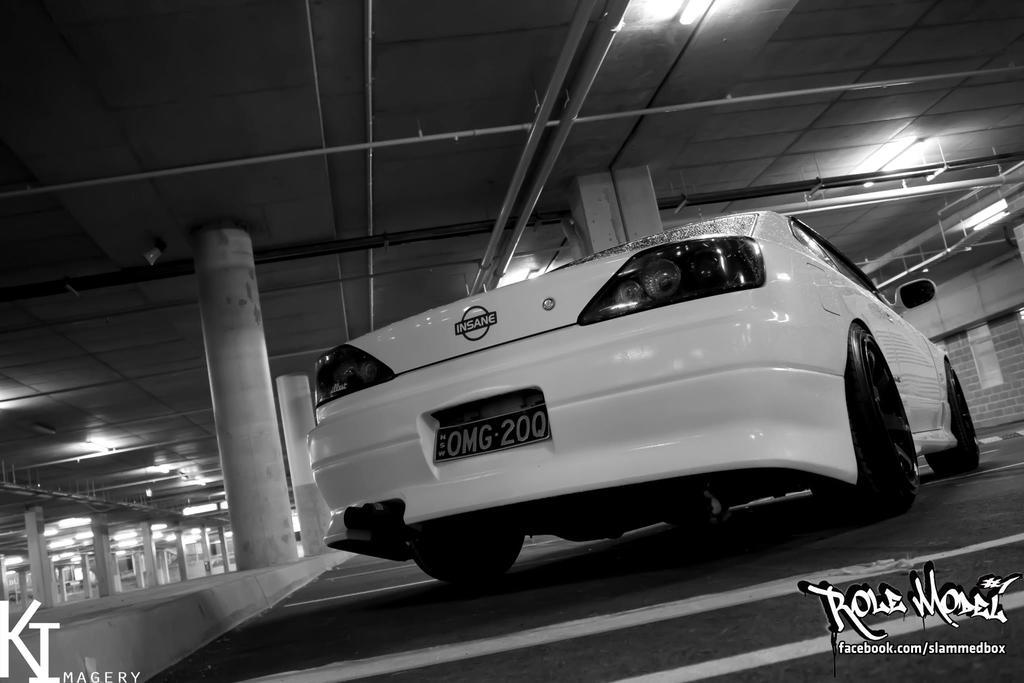What is the main subject in the foreground of the image? There is a car in the foreground of the image. Where is the car located in relation to the floor? The car is on the floor. What can be seen in the background of the image? There are pillars and lights attached to the ceiling in the background of the image. What type of plate is being used to protect the car from pests in the image? There is no plate or pests present in the image; the car is simply on the floor. 